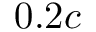<formula> <loc_0><loc_0><loc_500><loc_500>0 . 2 c</formula> 